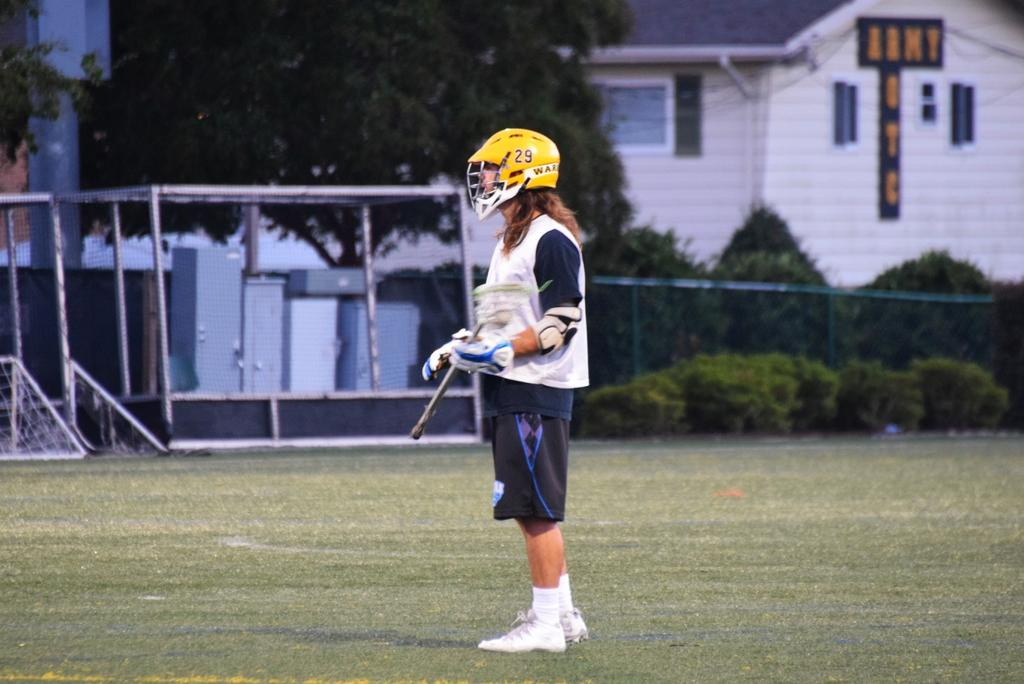What is the main subject of the image? There is a person standing in the center of the image. What is the person standing on? The person is standing on grass. What can be seen in the background of the image? There is fencing, trees, plants, a house, and grass in the background of the image. What type of pancake is being weighed on the scale in the image? There is no pancake or scale present in the image. 